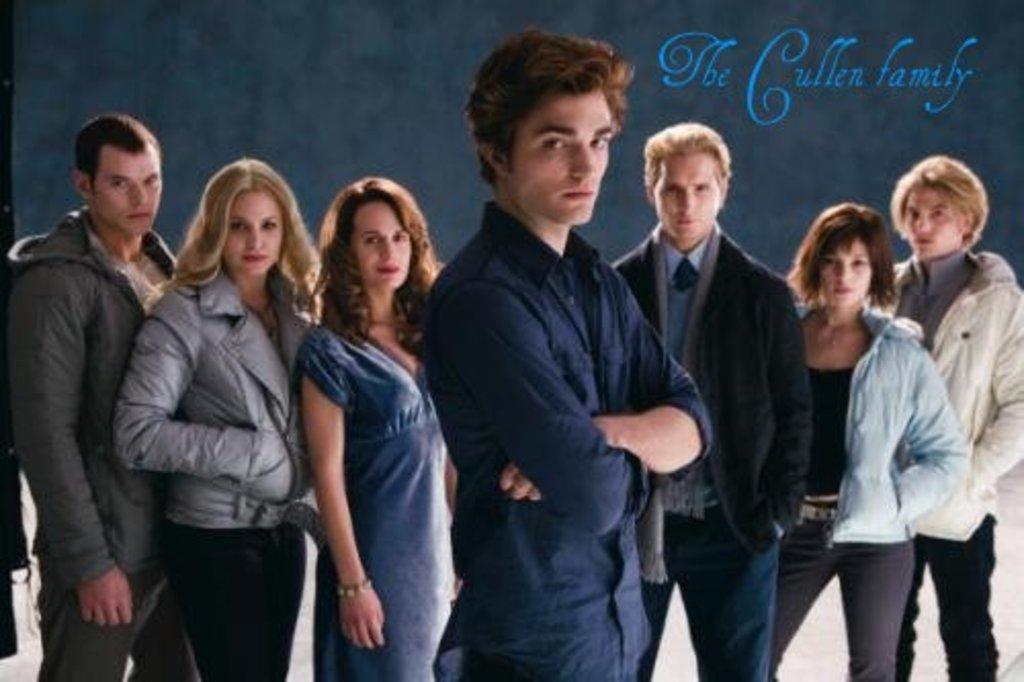Could you give a brief overview of what you see in this image? In this image we can see a few persons standing and in the background, we can see a black color poster with some text. 